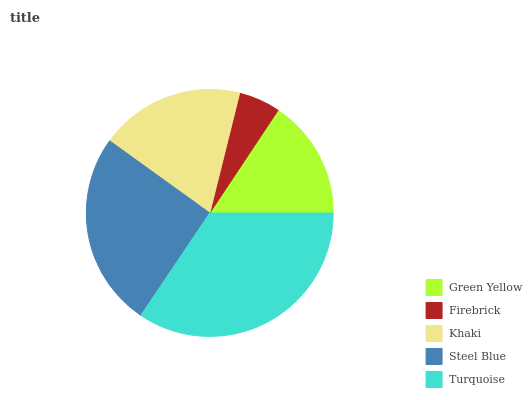Is Firebrick the minimum?
Answer yes or no. Yes. Is Turquoise the maximum?
Answer yes or no. Yes. Is Khaki the minimum?
Answer yes or no. No. Is Khaki the maximum?
Answer yes or no. No. Is Khaki greater than Firebrick?
Answer yes or no. Yes. Is Firebrick less than Khaki?
Answer yes or no. Yes. Is Firebrick greater than Khaki?
Answer yes or no. No. Is Khaki less than Firebrick?
Answer yes or no. No. Is Khaki the high median?
Answer yes or no. Yes. Is Khaki the low median?
Answer yes or no. Yes. Is Steel Blue the high median?
Answer yes or no. No. Is Steel Blue the low median?
Answer yes or no. No. 